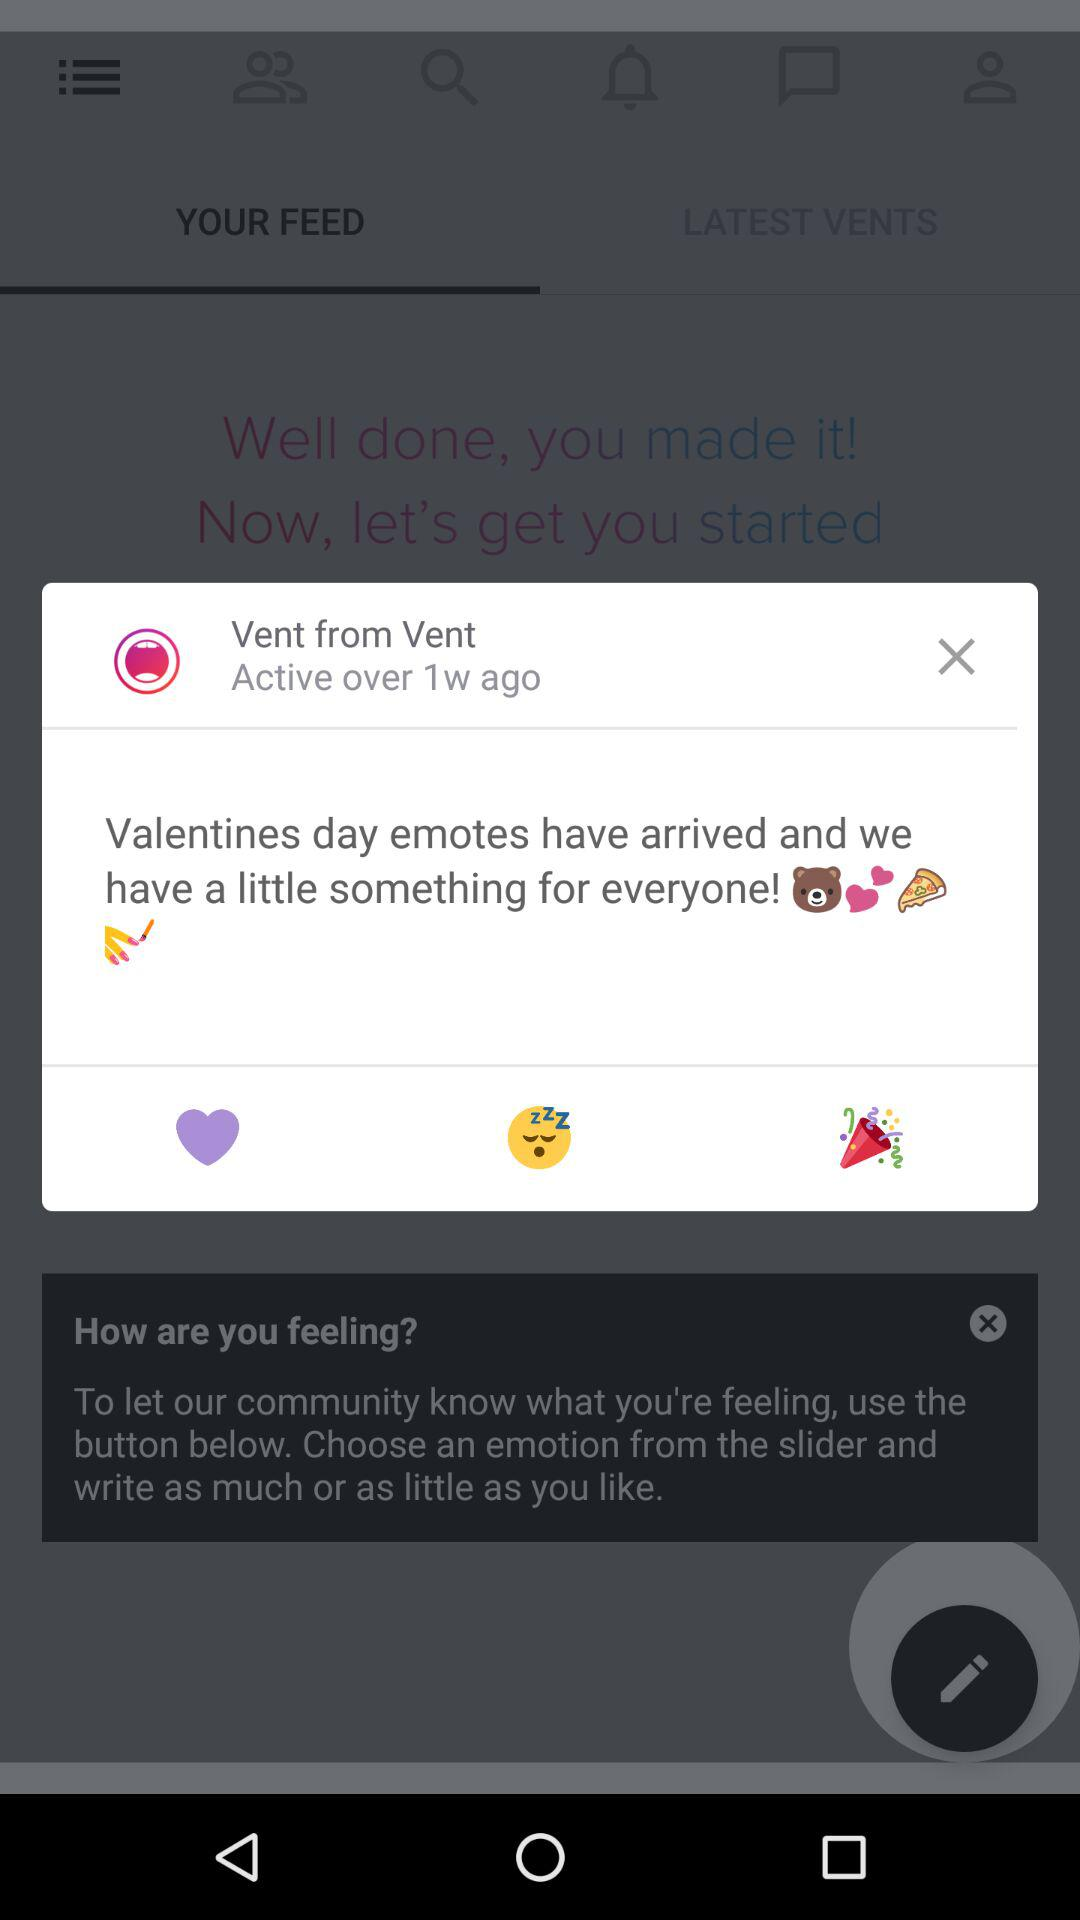What is the name of the application? The name of the application is "Vent". 